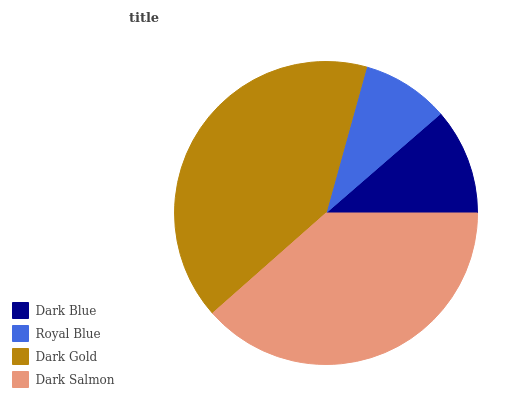Is Royal Blue the minimum?
Answer yes or no. Yes. Is Dark Gold the maximum?
Answer yes or no. Yes. Is Dark Gold the minimum?
Answer yes or no. No. Is Royal Blue the maximum?
Answer yes or no. No. Is Dark Gold greater than Royal Blue?
Answer yes or no. Yes. Is Royal Blue less than Dark Gold?
Answer yes or no. Yes. Is Royal Blue greater than Dark Gold?
Answer yes or no. No. Is Dark Gold less than Royal Blue?
Answer yes or no. No. Is Dark Salmon the high median?
Answer yes or no. Yes. Is Dark Blue the low median?
Answer yes or no. Yes. Is Dark Gold the high median?
Answer yes or no. No. Is Dark Gold the low median?
Answer yes or no. No. 